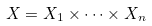Convert formula to latex. <formula><loc_0><loc_0><loc_500><loc_500>X = X _ { 1 } \times \dots \times X _ { n }</formula> 